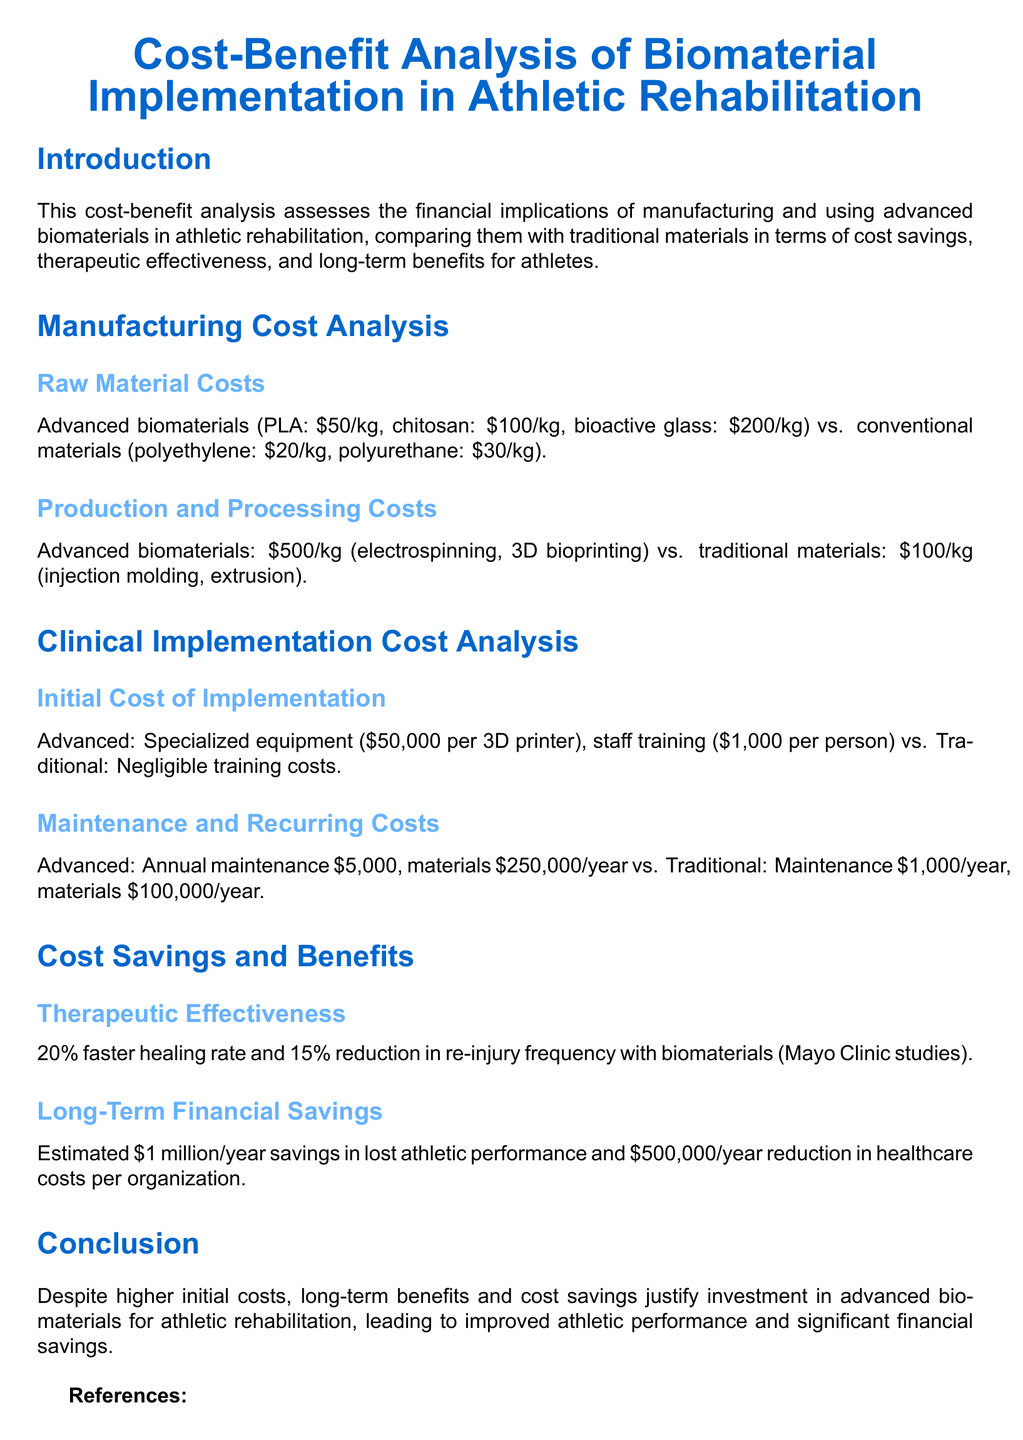What are the costs of PLA and chitosan? The costs for PLA and chitosan are $50/kg and $100/kg, respectively.
Answer: $50/kg, $100/kg What is the production cost of advanced biomaterials? The production cost for advanced biomaterials is $500/kg.
Answer: $500/kg What is the initial implementation cost for specialized equipment? The initial cost for specialized equipment is $50,000 per 3D printer.
Answer: $50,000 What is the annual maintenance cost for advanced biomaterials? The annual maintenance cost for advanced biomaterials is $5,000.
Answer: $5,000 What is the estimated annual savings in lost athletic performance? The estimated annual savings in lost athletic performance is $1 million.
Answer: $1 million What percentage reduction in re-injury frequency is noted with biomaterials? There is a 15% reduction in re-injury frequency with biomaterials.
Answer: 15% How much are the raw material costs for polyethylene? The raw material cost for polyethylene is $20/kg.
Answer: $20/kg What is the faster healing rate associated with advanced biomaterials? The faster healing rate associated with advanced biomaterials is 20%.
Answer: 20% What is the annual material cost for traditional materials? The annual material cost for traditional materials is $100,000/year.
Answer: $100,000/year 